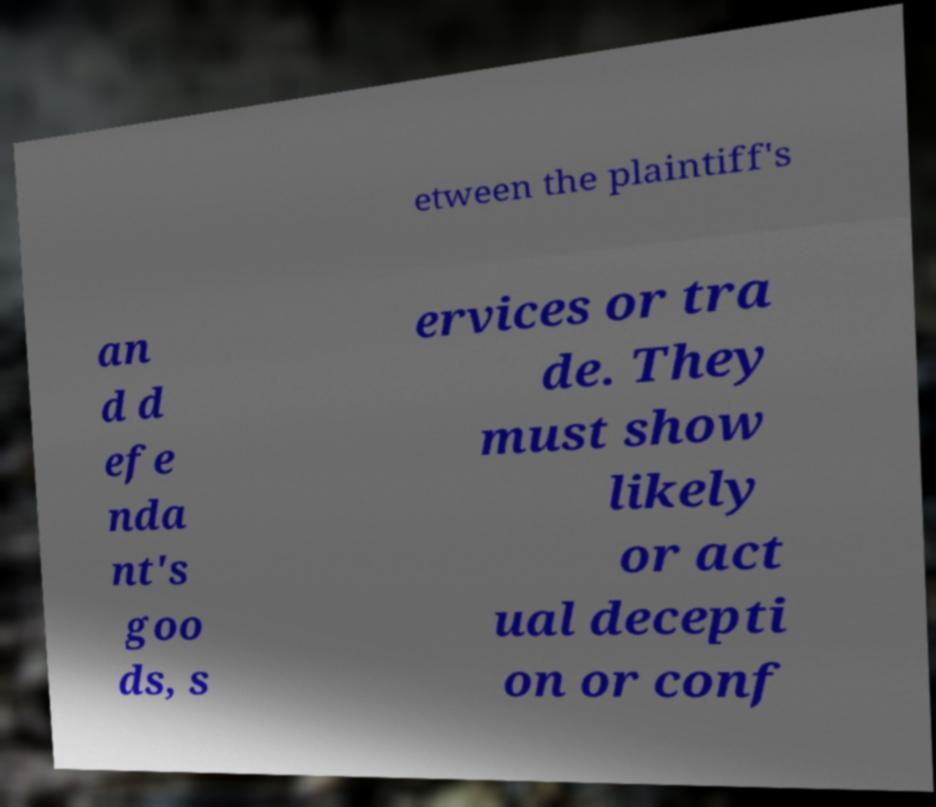For documentation purposes, I need the text within this image transcribed. Could you provide that? etween the plaintiff's an d d efe nda nt's goo ds, s ervices or tra de. They must show likely or act ual decepti on or conf 